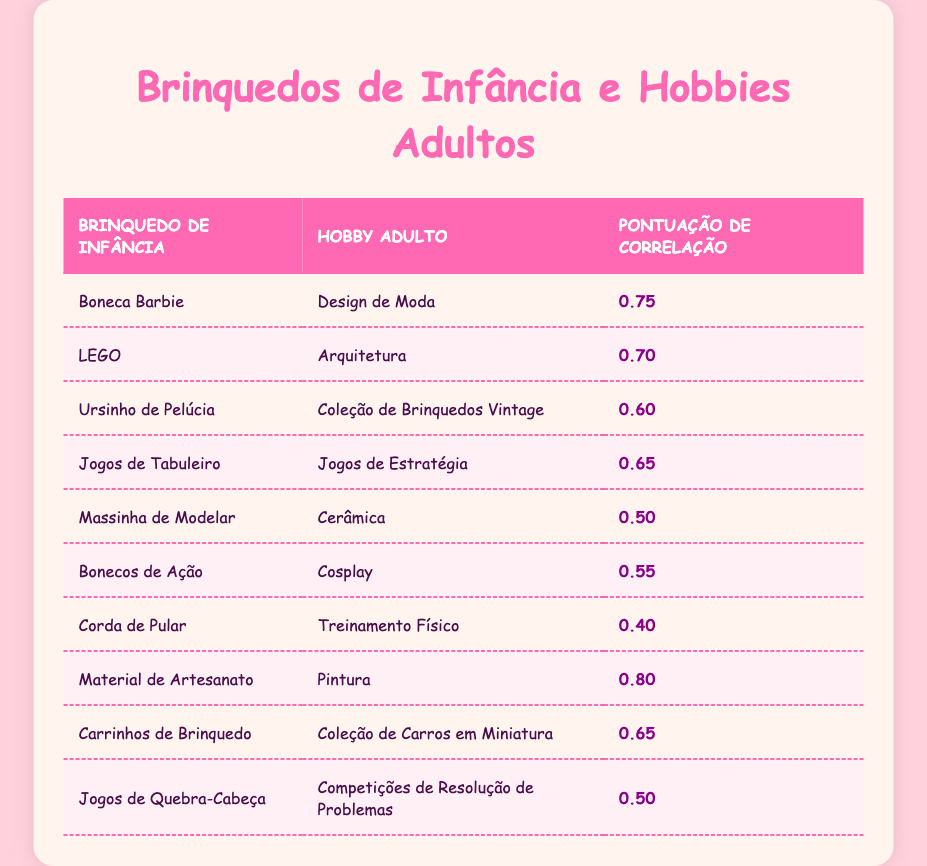What is the correlation score between the Barbie Doll and the adult hobby of Fashion Design? The table shows that the correlation score between the Barbie Doll and Fashion Design is 0.75. Just locate the row corresponding to "Boneca Barbie" and check the value in the "Pontuação de Correlação" column.
Answer: 0.75 Which childhood toy has the highest correlation score with an adult hobby? By scanning through the table, we can see that "Material de Artesanato" has the highest correlation score of 0.80 with the adult hobby of "Pintura." This is the highest value in the "Pontuação de Correlação" column.
Answer: 0.80 Is there a correlation between Action Figures and any adult hobby? Yes, according to the table, Action Figures have a correlation score of 0.55 with the hobby of Cosplay. We can simply check the entry for "Bonecos de Ação" to find that it is greater than zero.
Answer: Yes Which adult hobby is most commonly associated with LEGO? The adult hobby most associated with LEGO, according to the table, is "Arquitetura," with a correlation score of 0.70. This can be found by locating the row for LEGO and checking the corresponding hobby.
Answer: Arquitetura What is the average correlation score of the toys related to visual arts, like Arts and Crafts Supplies and Play-Doh? To find the average, we first identify the relevant toys: "Material de Artesanato" has a score of 0.80 and "Massinha de Modelar" has a score of 0.50. We then add these two scores: 0.80 + 0.50 = 1.30, and divide by 2 (the number of toys), which gives an average of 0.65.
Answer: 0.65 How many childhood toys have a correlation score above 0.60? Locating the relevant rows in the table, we see that four childhood toys have scores above 0.60: "Boneca Barbie" (0.75), "LEGO" (0.70), "Ursinho de Pelúcia" (0.60), and "Jogos de Tabuleiro" (0.65). Therefore, the count is four.
Answer: 4 What is the correlation score difference between the toys with the highest and the lowest correlations? The highest correlation score is 0.80 (Material de Artesanato) and the lowest score is 0.40 (Corda de Pular). The difference is calculated by subtracting the lowest score from the highest score: 0.80 - 0.40 = 0.40.
Answer: 0.40 Are there any childhood toys associated with outdoor activities? Yes, the “Corda de Pular,” with a correlation score of 0.40, is associated with the adult hobby of “Treinamento Físico,” which often involves outdoor activities. The table confirms this association by listing the relevant entries.
Answer: Yes 